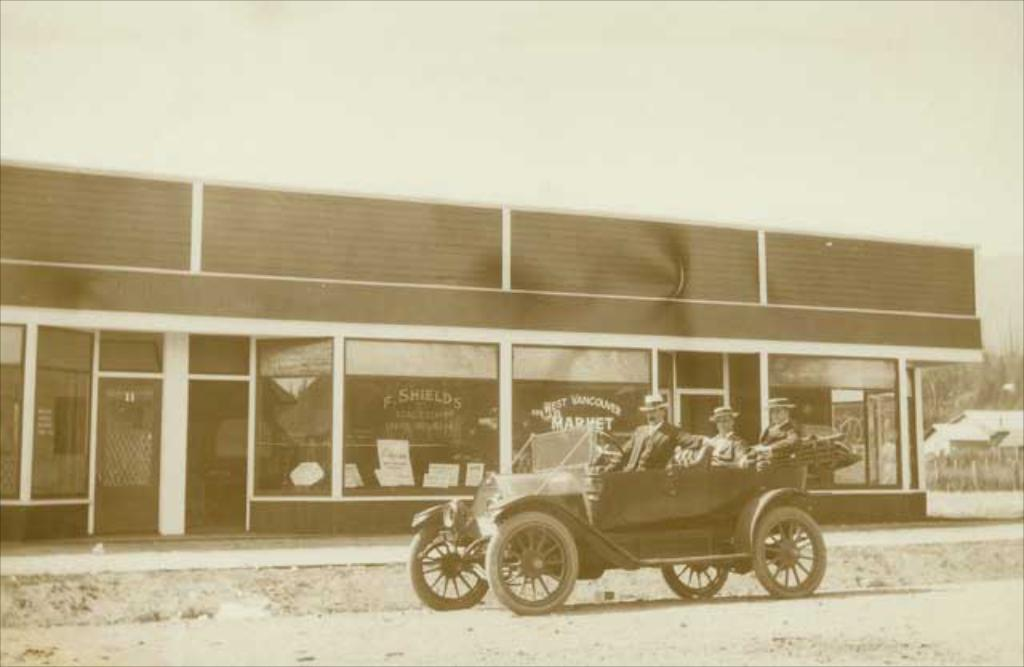How many people are sitting on the car in the image? There are three persons sitting on the car in the image. What can be seen in the background of the image? There are buildings, plants, trees, and the sky visible in the background of the image. What type of silk is draped around the neck of the person sitting on the car? There is no silk or any clothing item mentioned around the neck of the person sitting on the car in the image. 